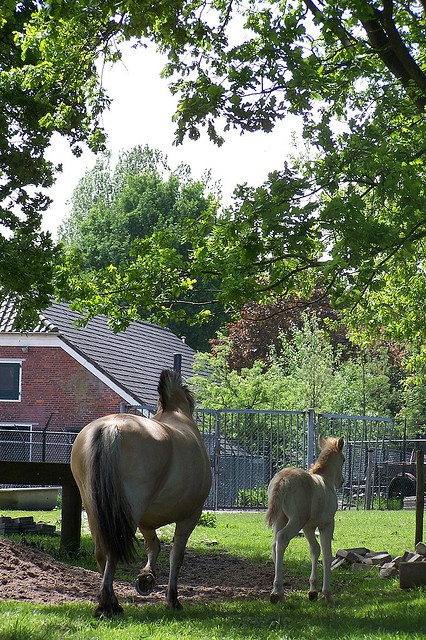Describe the objects in this image and their specific colors. I can see horse in darkgreen, black, gray, and darkgray tones, horse in darkgreen, black, and gray tones, and car in darkgreen, black, gray, and darkgray tones in this image. 